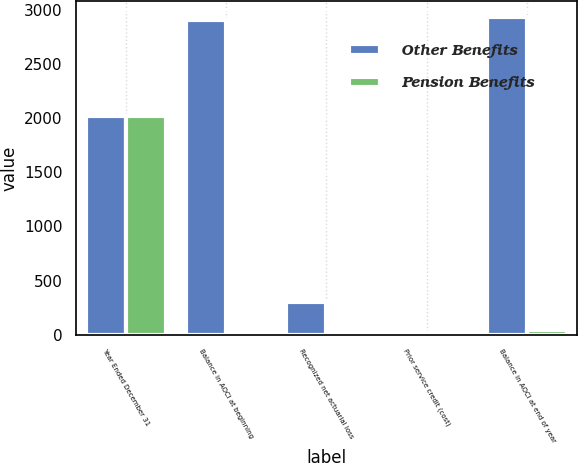Convert chart to OTSL. <chart><loc_0><loc_0><loc_500><loc_500><stacked_bar_chart><ecel><fcel>Year Ended December 31<fcel>Balance in AOCI at beginning<fcel>Recognized net actuarial loss<fcel>Prior service credit (cost)<fcel>Balance in AOCI at end of year<nl><fcel>Other Benefits<fcel>2016<fcel>2907<fcel>301<fcel>17<fcel>2932<nl><fcel>Pension Benefits<fcel>2016<fcel>26<fcel>7<fcel>4<fcel>48<nl></chart> 